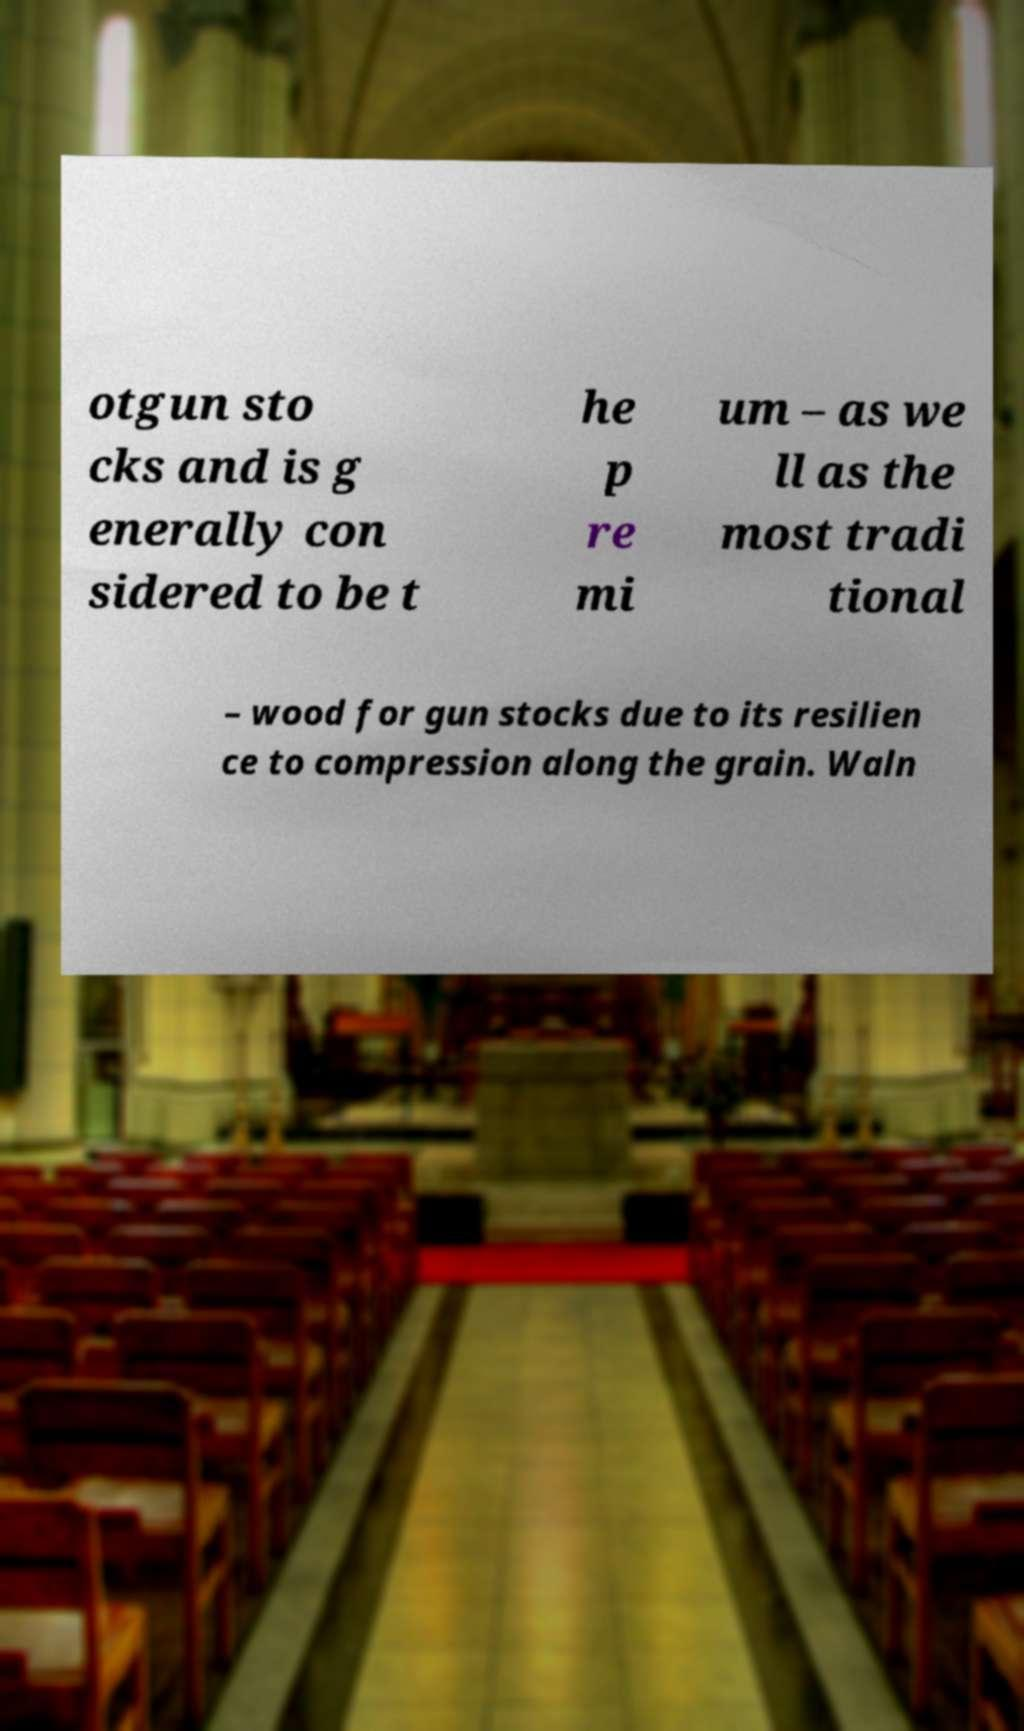Can you accurately transcribe the text from the provided image for me? otgun sto cks and is g enerally con sidered to be t he p re mi um – as we ll as the most tradi tional – wood for gun stocks due to its resilien ce to compression along the grain. Waln 